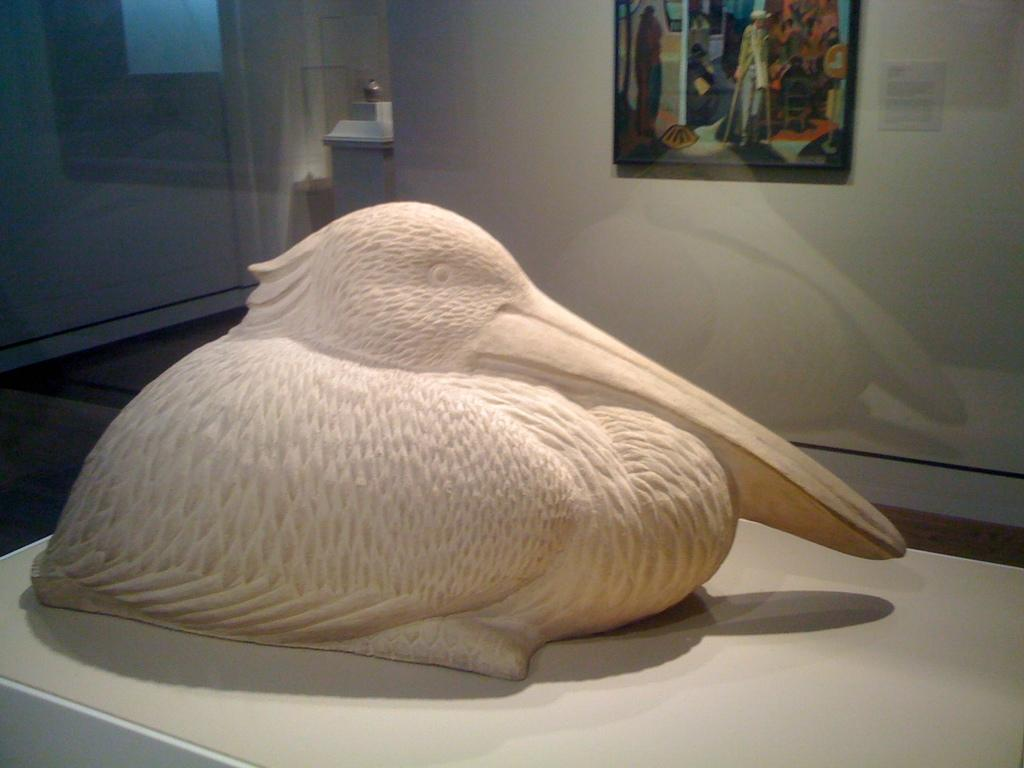What is the main subject on the white color surface in the image? There is a statue on a white color surface in the image. What can be seen on the wall in the image? There is a photo frame on the wall in the image. What is the color of the object on the floor in the image? There is a white color object on the floor in the image. Can you tell me how many girls are walking in the image? There are no girls or walking depicted in the image. What type of suggestion is given by the statue in the image? The statue is not giving any suggestions, as it is an inanimate object. 